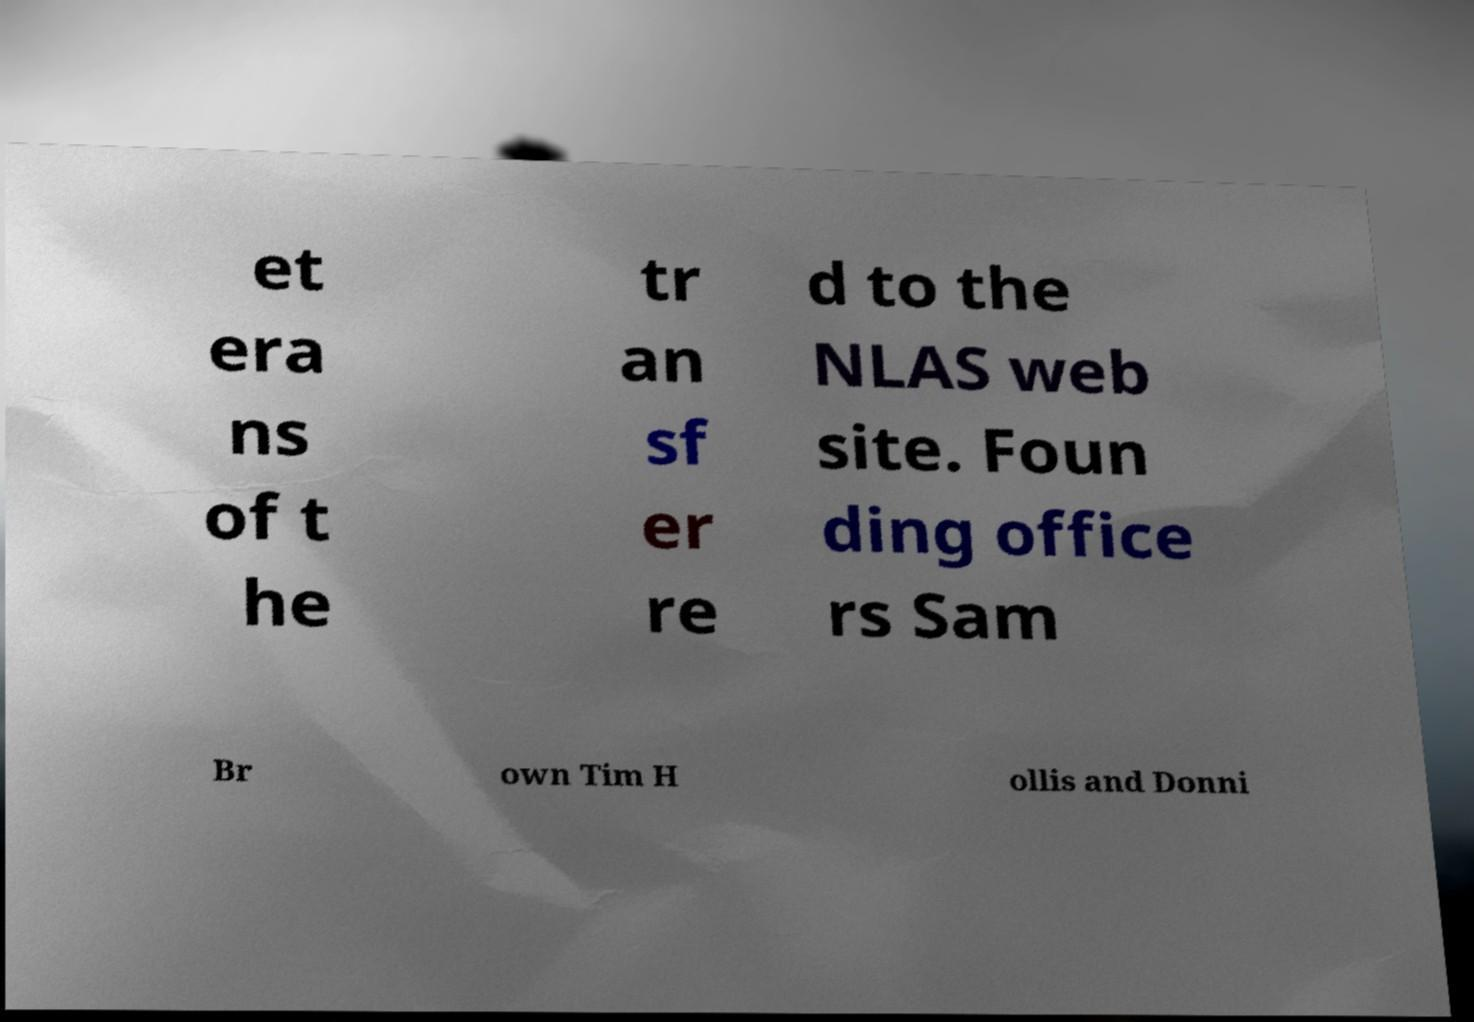Please identify and transcribe the text found in this image. et era ns of t he tr an sf er re d to the NLAS web site. Foun ding office rs Sam Br own Tim H ollis and Donni 